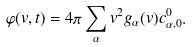<formula> <loc_0><loc_0><loc_500><loc_500>\varphi ( v , t ) = 4 \pi \sum _ { \alpha } v ^ { 2 } g _ { \alpha } ( v ) c ^ { 0 } _ { \alpha , { 0 } } .</formula> 